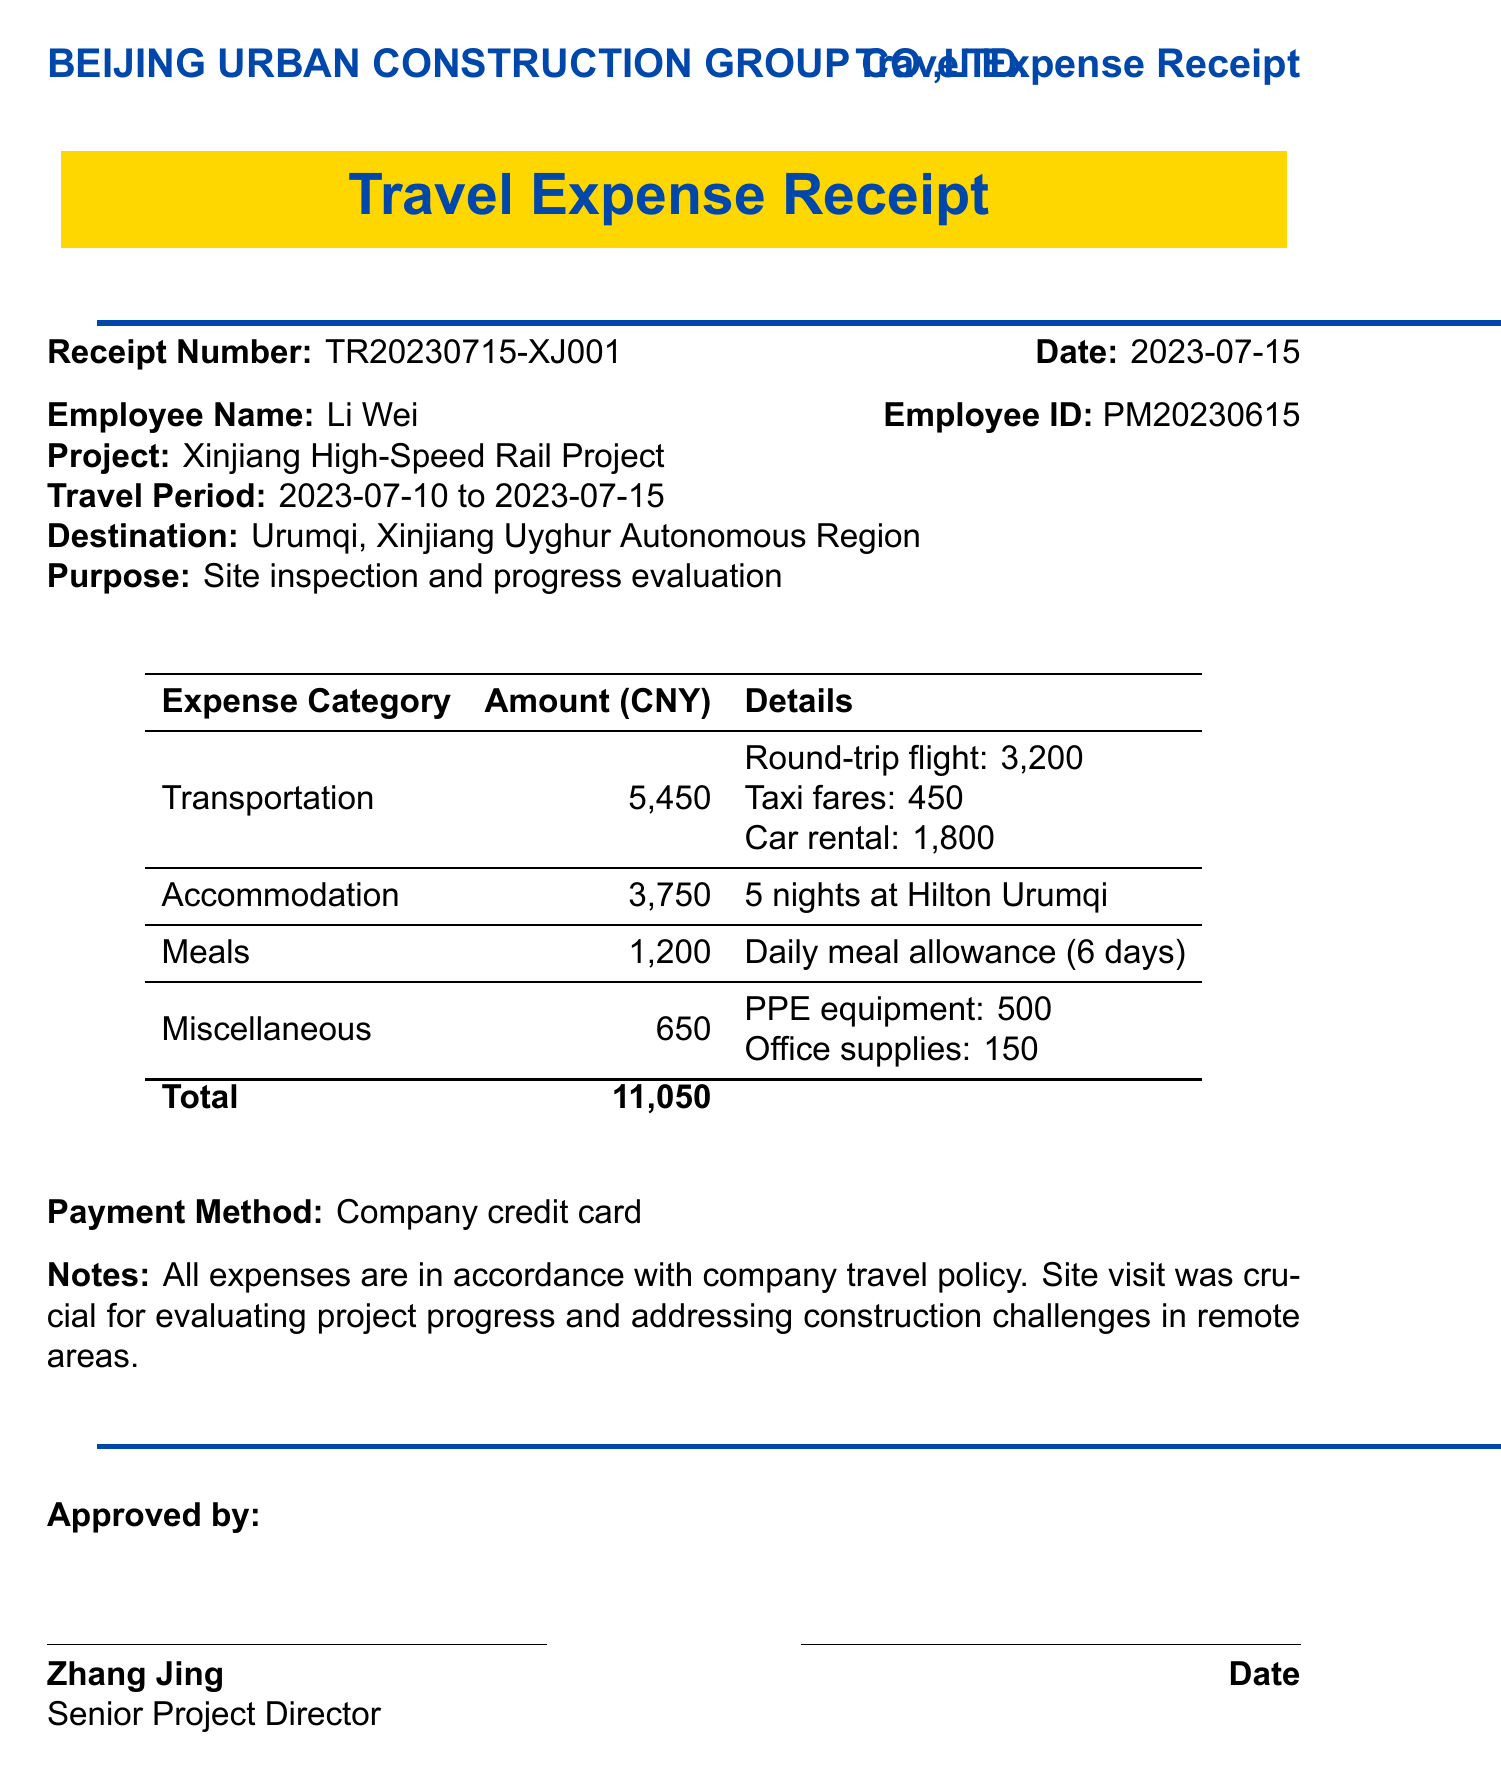What is the total amount of expenses? The total amount is listed in the document under the total expenses section, which is 11050 CNY.
Answer: 11050 Who is the employee associated with this receipt? The employee's name appears in the receipt details section, being Li Wei.
Answer: Li Wei What was the destination for the site visit? The destination is mentioned in the travel details section, which is Urumqi, Xinjiang Uyghur Autonomous Region.
Answer: Urumqi, Xinjiang Uyghur Autonomous Region What payment method was used for the expenses? The payment method is specified clearly in the document, which states it was a company credit card.
Answer: Company credit card How many nights did the employee stay at the hotel? The number of nights is listed in the accommodation section, which indicates 5 nights at Hilton Urumqi.
Answer: 5 nights What was the purpose of the trip? The purpose is mentioned in the travel details section, which states it was for site inspection and progress evaluation.
Answer: Site inspection and progress evaluation Who approved the expenses? The approver's name is found in the approval section, noted as Zhang Jing, Senior Project Director.
Answer: Zhang Jing What is the receipt number? The receipt number is found at the top of the document, which is TR20230715-XJ001.
Answer: TR20230715-XJ001 How much was spent on meals? The total amount for meals is detailed in the expenses section, which shows 1200 CNY for the daily meal allowance.
Answer: 1200 